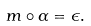Convert formula to latex. <formula><loc_0><loc_0><loc_500><loc_500>m \circ \alpha = \epsilon .</formula> 